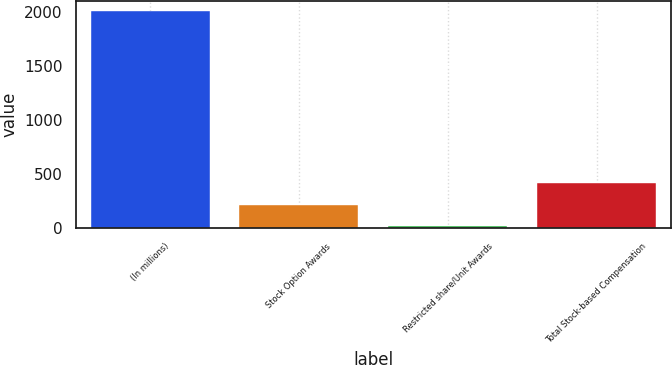Convert chart to OTSL. <chart><loc_0><loc_0><loc_500><loc_500><bar_chart><fcel>(In millions)<fcel>Stock Option Awards<fcel>Restricted share/Unit Awards<fcel>Total Stock-based Compensation<nl><fcel>2008<fcel>219.88<fcel>21.2<fcel>418.56<nl></chart> 